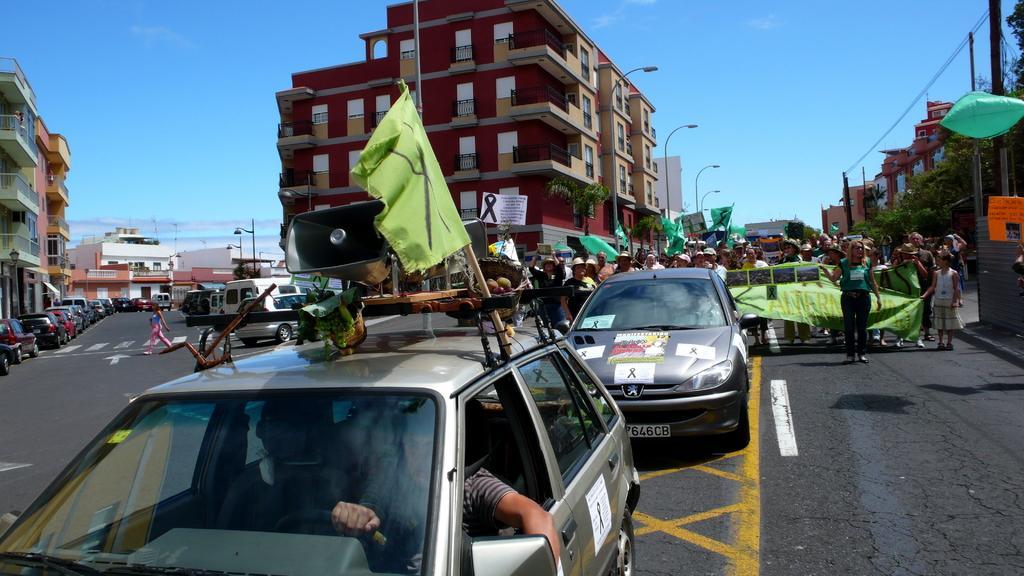Can you describe this image briefly? In the center of the image there is a road. There are vehicles. There are people holding a banner on the road. In the background of the image there are buildings,ski,poles. 